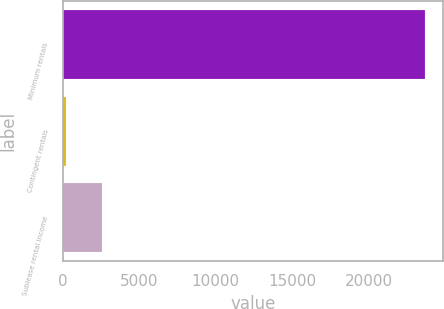Convert chart. <chart><loc_0><loc_0><loc_500><loc_500><bar_chart><fcel>Minimum rentals<fcel>Contingent rentals<fcel>Sublease rental income<nl><fcel>23688<fcel>196<fcel>2545.2<nl></chart> 